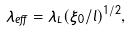Convert formula to latex. <formula><loc_0><loc_0><loc_500><loc_500>\lambda _ { e f f } = \lambda _ { L } ( \xi _ { 0 } / l ) ^ { 1 / 2 } ,</formula> 